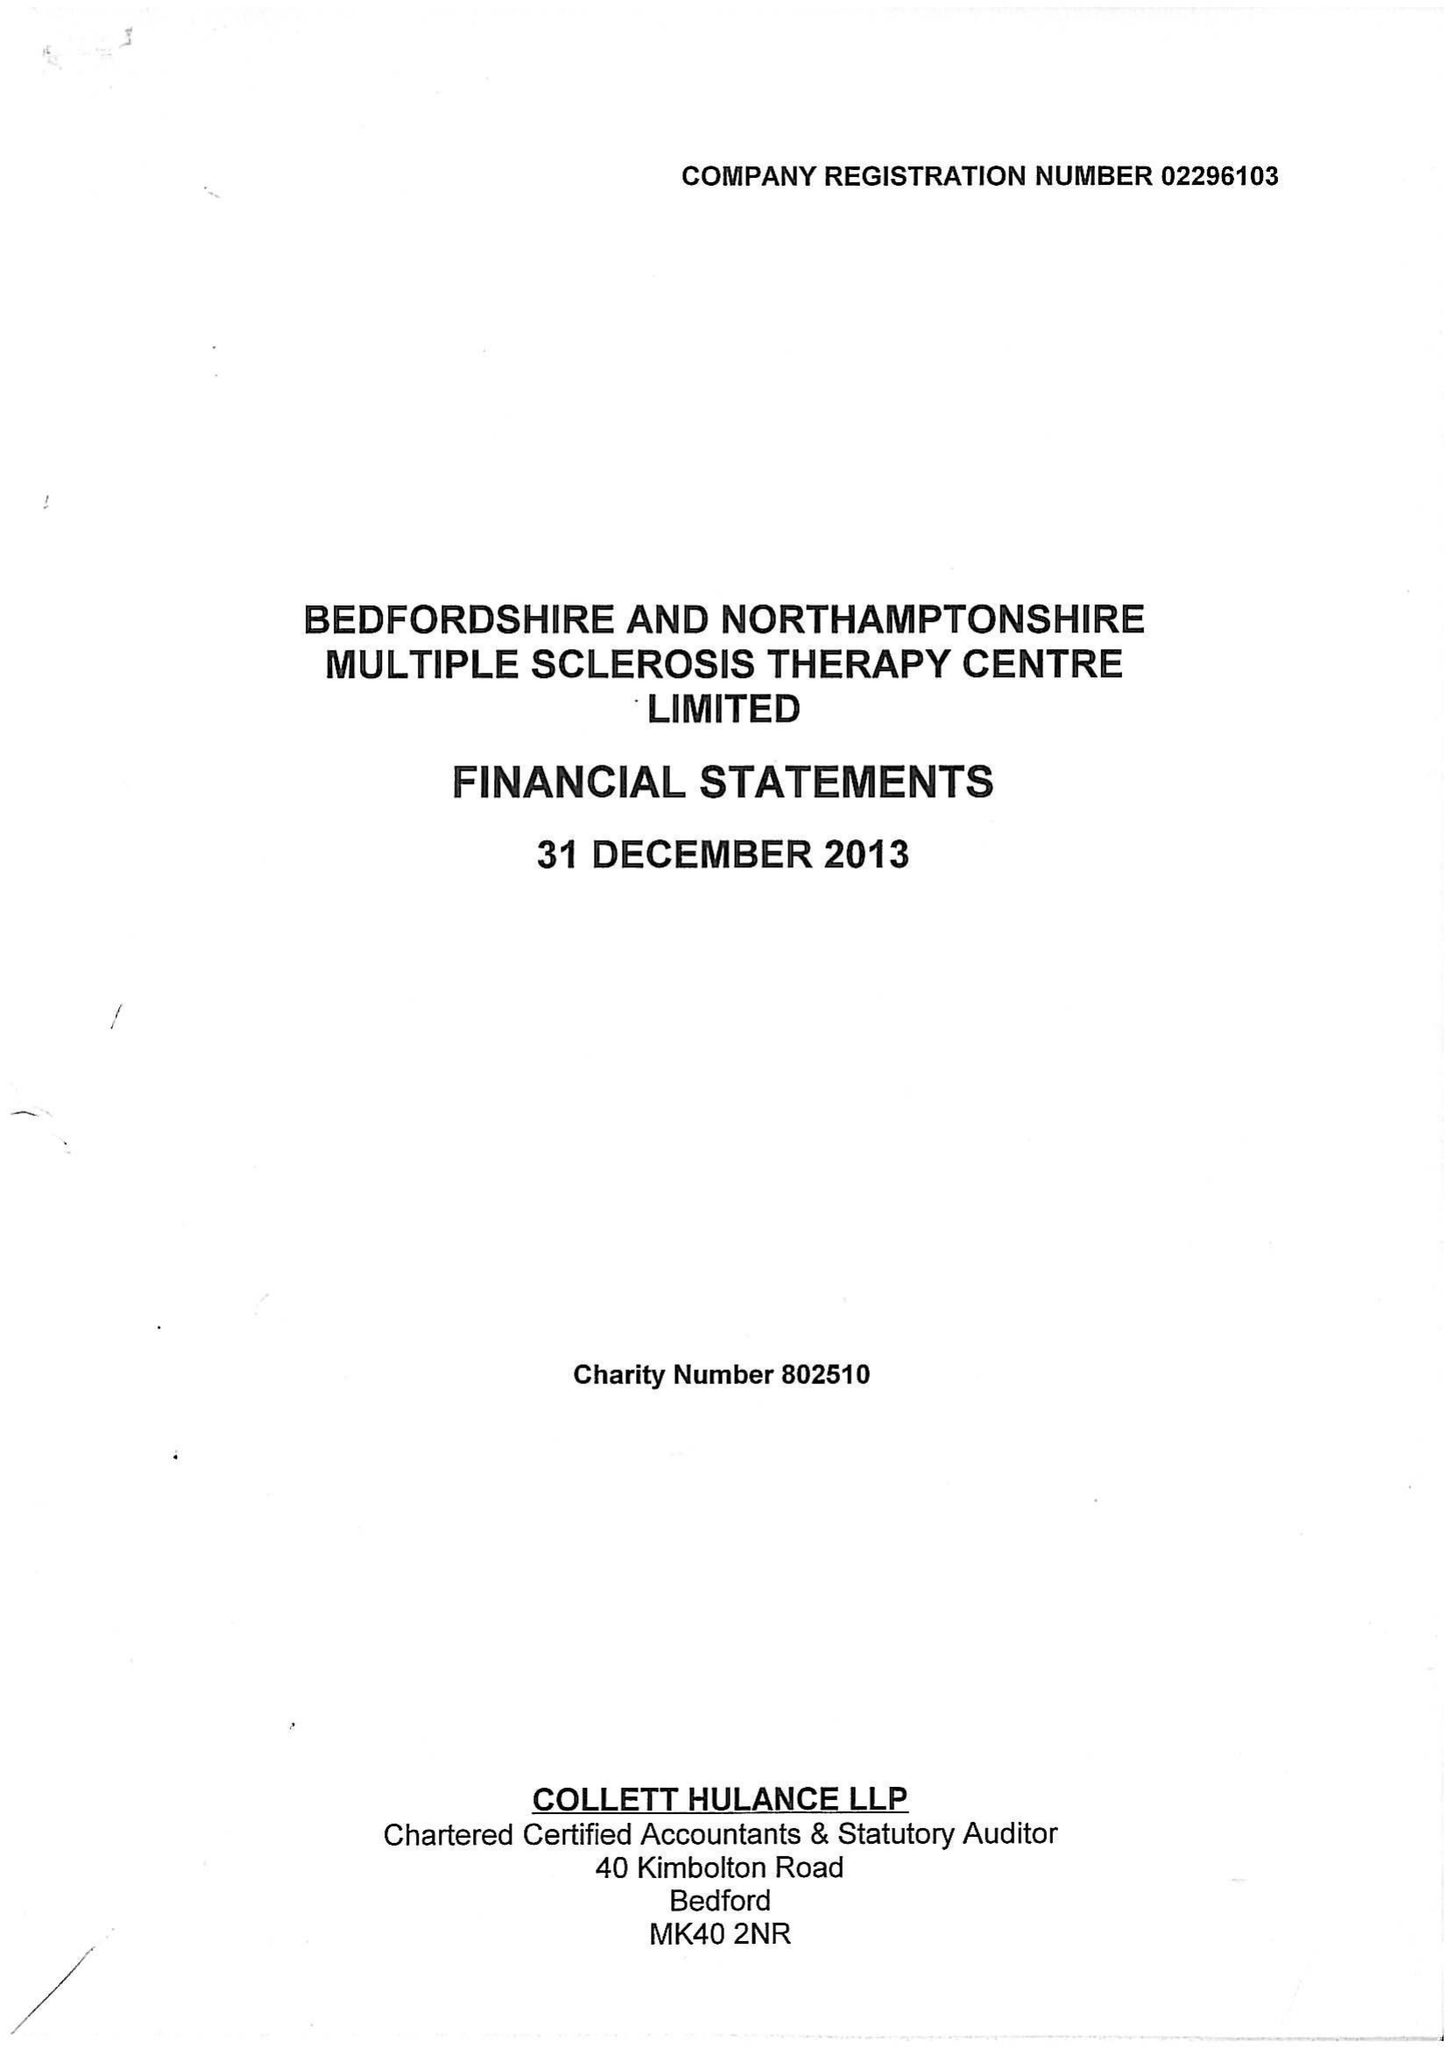What is the value for the spending_annually_in_british_pounds?
Answer the question using a single word or phrase. 373484.00 